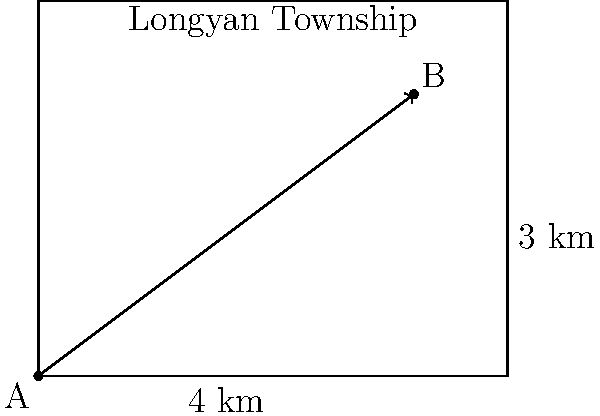In Longyan Township, there are two important landmarks: the ancient Drum Tower (point A) and the scenic Longyan Lake (point B). On the map, the distance between these two points is represented by a vector. If each grid unit represents 1 km, what is the magnitude of this vector? To find the magnitude of the vector representing the distance between points A and B, we can follow these steps:

1) From the map, we can see that the horizontal distance between A and B is 4 km, and the vertical distance is 3 km.

2) We can represent this as a vector $\vec{v} = (4, 3)$.

3) To find the magnitude of this vector, we use the Pythagorean theorem:

   $|\vec{v}| = \sqrt{x^2 + y^2}$

   Where $x$ is the horizontal component and $y$ is the vertical component.

4) Substituting our values:

   $|\vec{v}| = \sqrt{4^2 + 3^2}$

5) Simplify:
   
   $|\vec{v}| = \sqrt{16 + 9} = \sqrt{25} = 5$

Therefore, the magnitude of the vector representing the distance between the Drum Tower and Longyan Lake is 5 km.
Answer: 5 km 